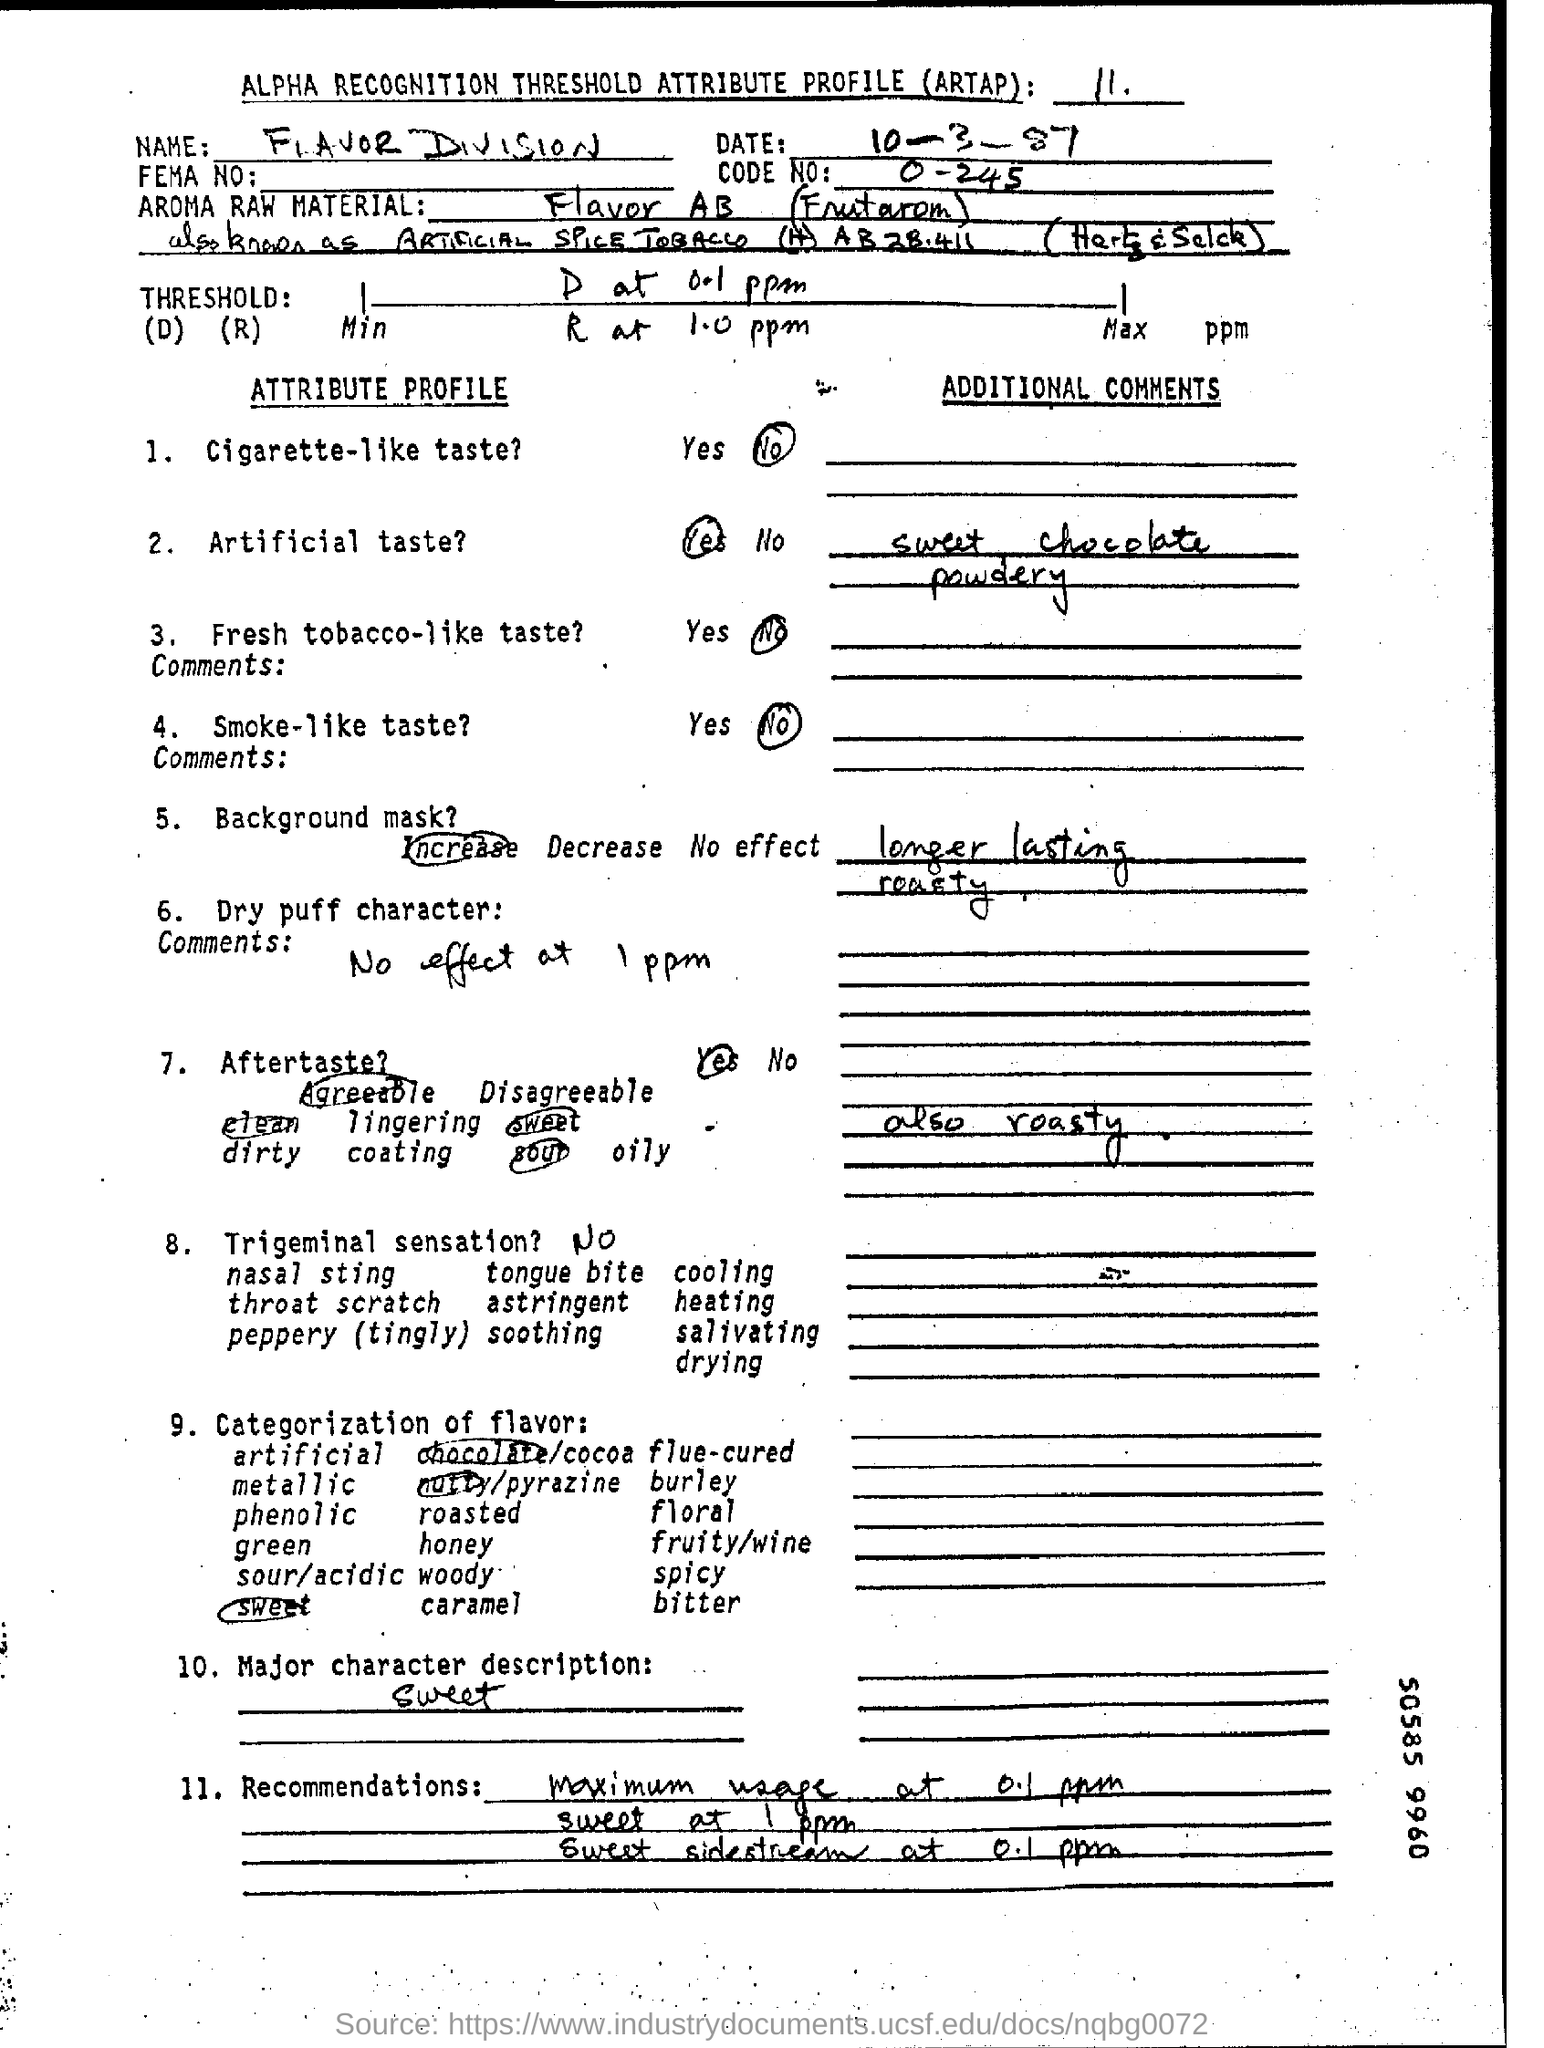Point out several critical features in this image. The product does not give a taste similar to that of a cigarette. Flavor AB (Frutarom) is used in this raw material. The major character description attributes Sweet as one of its major characteristics. The code number mentioned in the document is 0. The document refers to a code range of -245 to 0. ARTAP stands for Alpha Recognition Threshold Attribute Profile, which is a standardized format for presenting and exchanging data related to biometric identification and verification systems. 